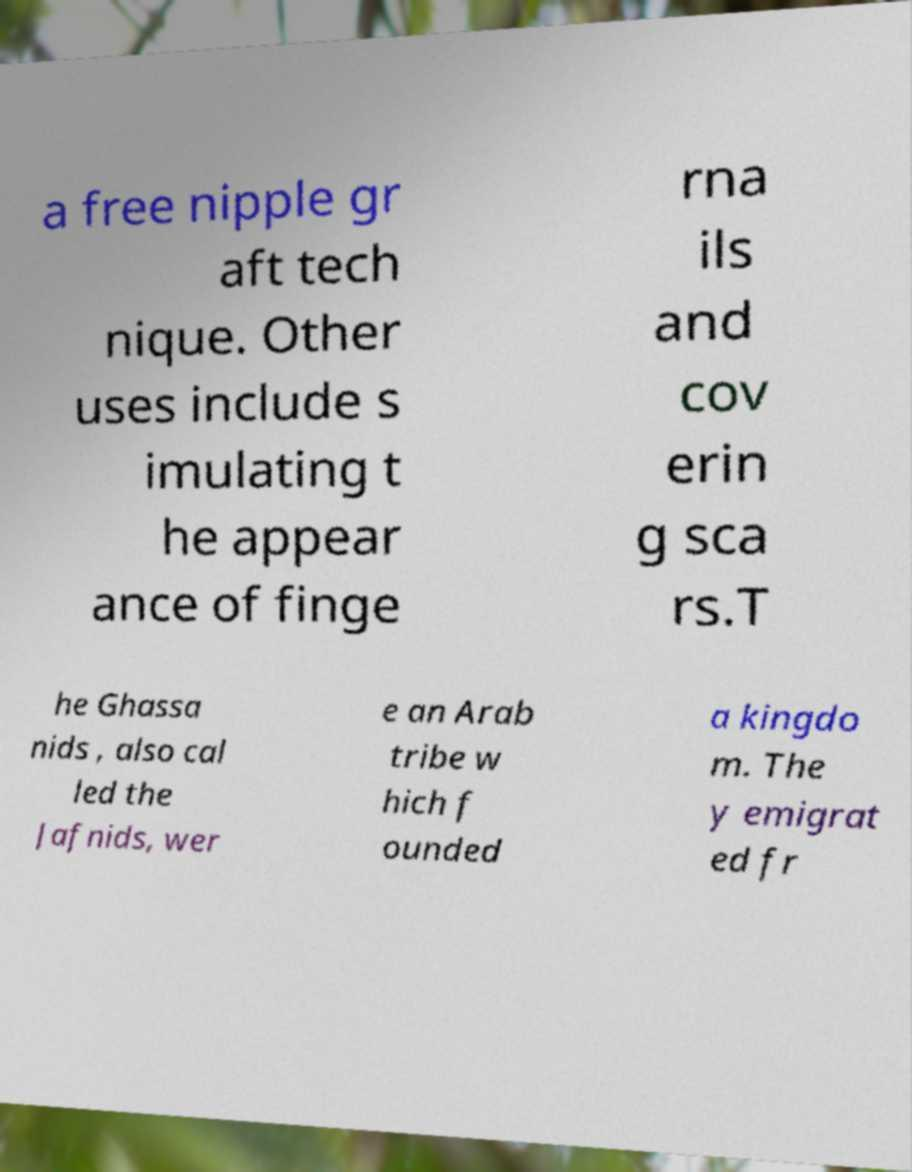Could you extract and type out the text from this image? a free nipple gr aft tech nique. Other uses include s imulating t he appear ance of finge rna ils and cov erin g sca rs.T he Ghassa nids , also cal led the Jafnids, wer e an Arab tribe w hich f ounded a kingdo m. The y emigrat ed fr 